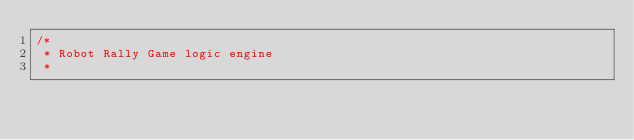Convert code to text. <code><loc_0><loc_0><loc_500><loc_500><_C#_>/*
 * Robot Rally Game logic engine
 *</code> 